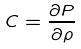Convert formula to latex. <formula><loc_0><loc_0><loc_500><loc_500>C = \frac { \partial P } { \partial \rho }</formula> 